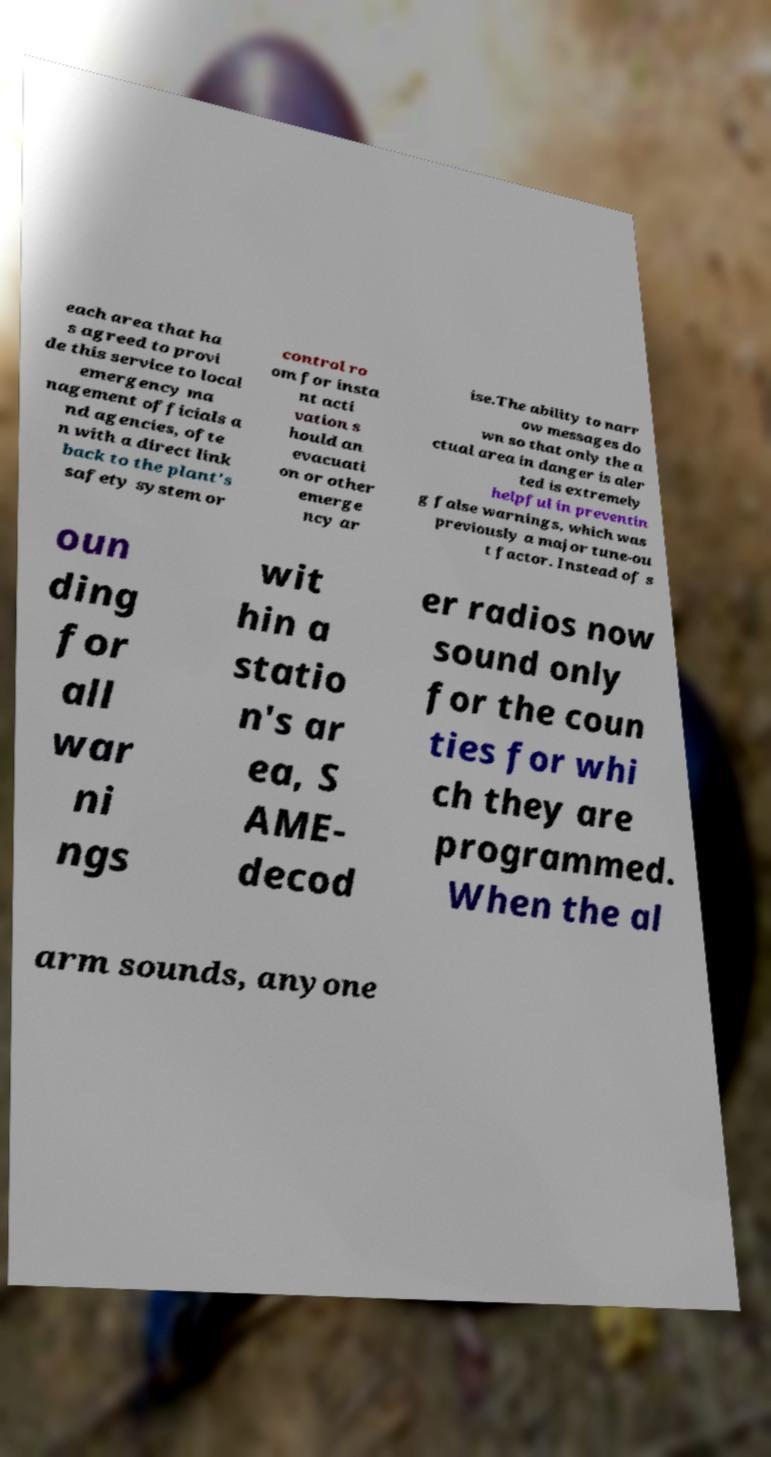What messages or text are displayed in this image? I need them in a readable, typed format. each area that ha s agreed to provi de this service to local emergency ma nagement officials a nd agencies, ofte n with a direct link back to the plant's safety system or control ro om for insta nt acti vation s hould an evacuati on or other emerge ncy ar ise.The ability to narr ow messages do wn so that only the a ctual area in danger is aler ted is extremely helpful in preventin g false warnings, which was previously a major tune-ou t factor. Instead of s oun ding for all war ni ngs wit hin a statio n's ar ea, S AME- decod er radios now sound only for the coun ties for whi ch they are programmed. When the al arm sounds, anyone 